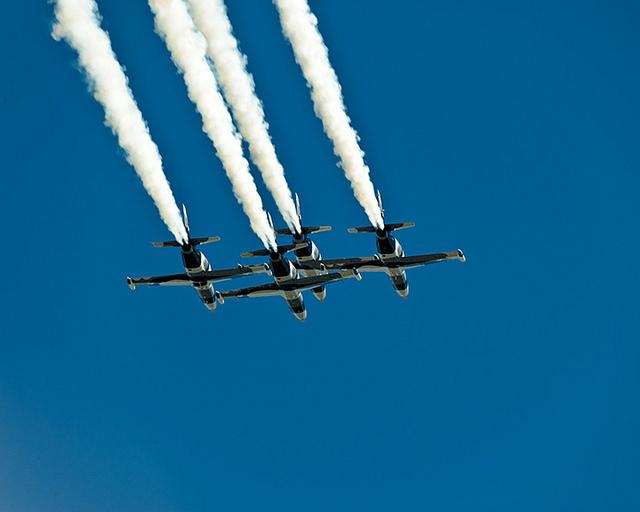How many jet planes are flying together in the sky with military formation? four 